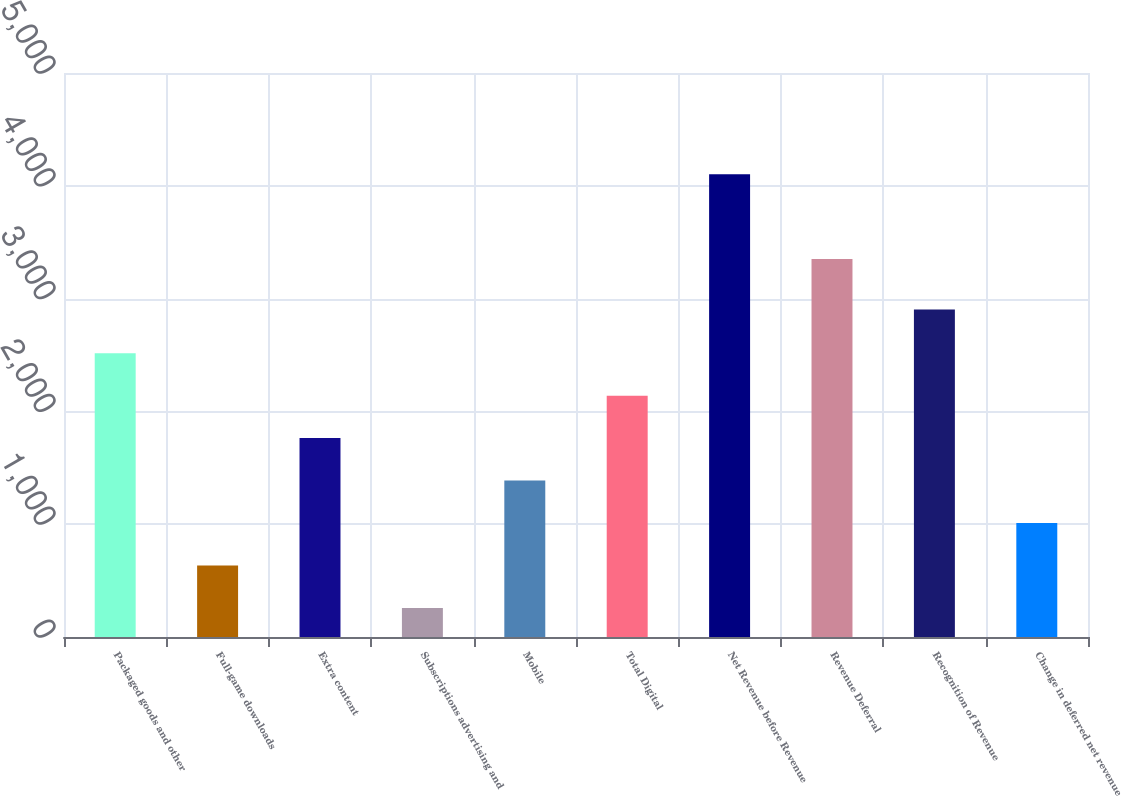<chart> <loc_0><loc_0><loc_500><loc_500><bar_chart><fcel>Packaged goods and other<fcel>Full-game downloads<fcel>Extra content<fcel>Subscriptions advertising and<fcel>Mobile<fcel>Total Digital<fcel>Net Revenue before Revenue<fcel>Revenue Deferral<fcel>Recognition of Revenue<fcel>Change in deferred net revenue<nl><fcel>2515.8<fcel>634.3<fcel>1763.2<fcel>258<fcel>1386.9<fcel>2139.5<fcel>4102.6<fcel>3350<fcel>2904<fcel>1010.6<nl></chart> 